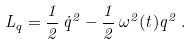Convert formula to latex. <formula><loc_0><loc_0><loc_500><loc_500>L _ { q } = \frac { 1 } { 2 } \, \dot { q } ^ { 2 } - \frac { 1 } { 2 } \, \omega ^ { 2 } ( t ) q ^ { 2 } \, .</formula> 